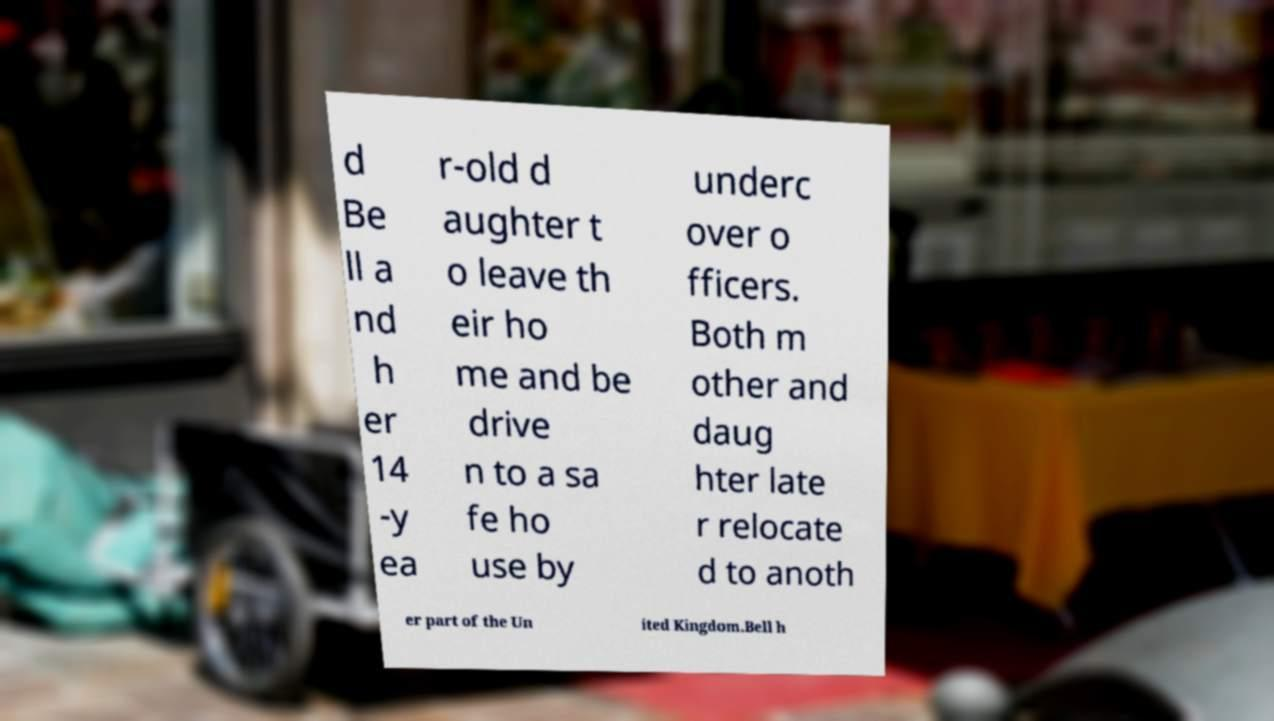Please read and relay the text visible in this image. What does it say? d Be ll a nd h er 14 -y ea r-old d aughter t o leave th eir ho me and be drive n to a sa fe ho use by underc over o fficers. Both m other and daug hter late r relocate d to anoth er part of the Un ited Kingdom.Bell h 